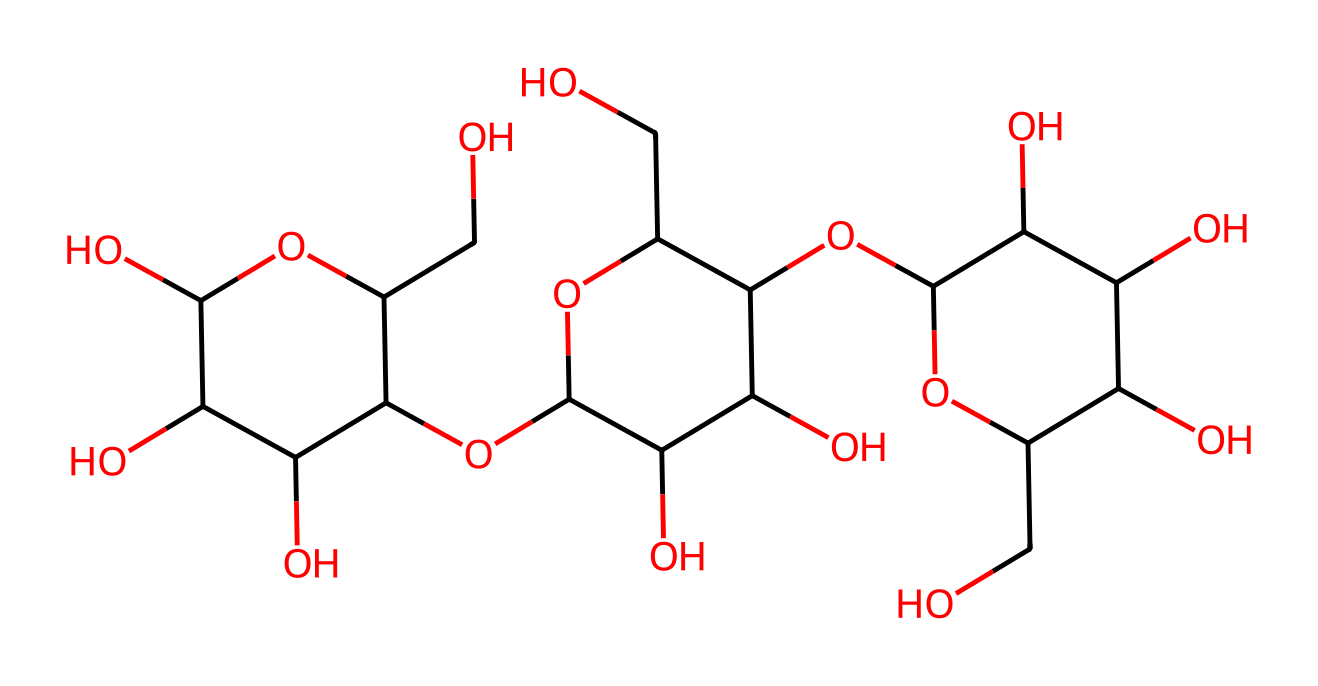What is the primary functional group present in this compound? The compound contains several hydroxyl (-OH) functional groups, which are indicated by the presence of oxygen atoms connected to hydrogen. These groups are responsible for the compound's solubility in water and other properties.
Answer: hydroxyl group How many carbon atoms does this compound have? By analyzing the structure, we can count the number of carbon atoms (each point in the skeletal structure represents a carbon atom). In this case, there are 15 carbon atoms present in the compound.
Answer: 15 What type of organic compound is primarily represented by this SMILES notation? The presence of multiple hydroxyl groups and the cyclic structure suggests that this compound is primarily a carbohydrate, specifically a type of sugar known as a polysaccharide.
Answer: polysaccharide What is the total number of oxygen atoms in the chemical structure? The number of oxygen atoms can be counted directly from the SMILES representation. After careful analysis, we find that there are 8 oxygen atoms in this compound.
Answer: 8 Does this compound have any chiral centers? By examining the structure for carbon atoms bonded to four different substituents, we find multiple chiral centers in the compound. This indicates that the compound can exist in different stereoisomeric forms.
Answer: yes What can be inferred about the solubility of this compound in water? Given the presence of several hydroxyl groups, which are polar and can form hydrogen bonds with water, we can infer that this compound is likely highly soluble in water.
Answer: highly soluble 